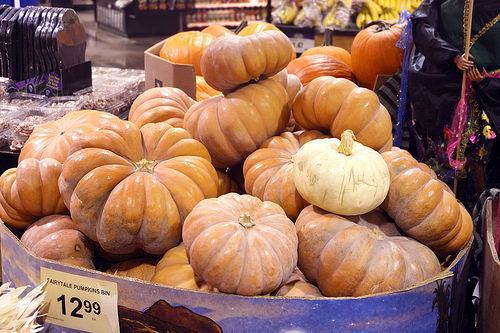<image>
Is there a pumpkin under the pumpkin? No. The pumpkin is not positioned under the pumpkin. The vertical relationship between these objects is different. Where is the pumpkin in relation to the box? Is it in the box? No. The pumpkin is not contained within the box. These objects have a different spatial relationship. Where is the pumpkin in relation to the pumpkin? Is it above the pumpkin? Yes. The pumpkin is positioned above the pumpkin in the vertical space, higher up in the scene. 